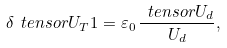Convert formula to latex. <formula><loc_0><loc_0><loc_500><loc_500>\delta \ t e n s o r { U } _ { T } 1 = \varepsilon _ { 0 } \, \frac { \ t e n s o r { U } _ { d } } { U _ { d } } ,</formula> 